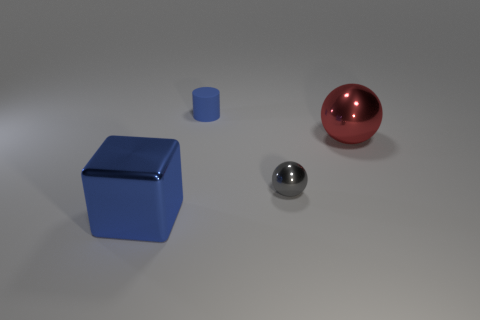Are there more matte cylinders than small green shiny blocks?
Provide a short and direct response. Yes. How many things are small balls right of the tiny blue rubber object or spheres?
Your answer should be very brief. 2. Are there any red spheres of the same size as the blue metal cube?
Offer a very short reply. Yes. Is the number of large metallic spheres less than the number of big purple cylinders?
Your response must be concise. No. How many cylinders are either blue shiny things or red objects?
Keep it short and to the point. 0. What number of tiny metal spheres are the same color as the cylinder?
Keep it short and to the point. 0. There is a object that is both behind the gray metallic thing and on the right side of the blue matte cylinder; how big is it?
Offer a very short reply. Large. Are there fewer blue objects behind the blue metal thing than big balls?
Ensure brevity in your answer.  No. Is the red object made of the same material as the blue block?
Provide a succinct answer. Yes. How many objects are either tiny gray shiny things or blue matte cylinders?
Ensure brevity in your answer.  2. 